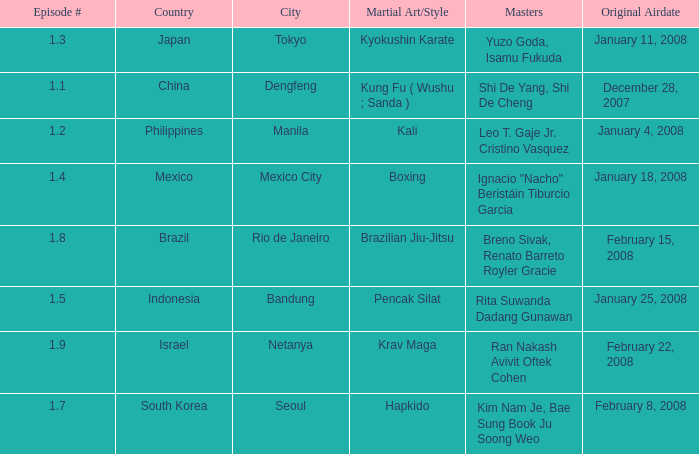When did the episode featuring a master using Brazilian jiu-jitsu air? February 15, 2008. 